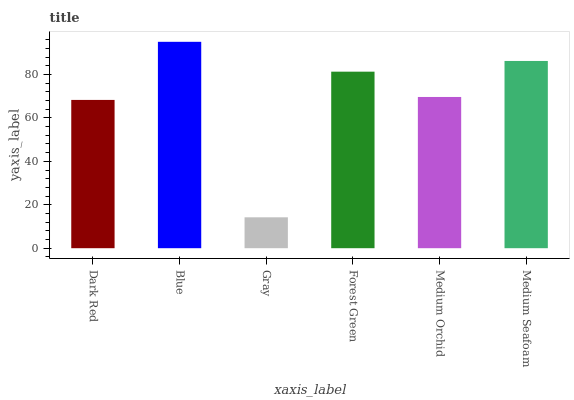Is Gray the minimum?
Answer yes or no. Yes. Is Blue the maximum?
Answer yes or no. Yes. Is Blue the minimum?
Answer yes or no. No. Is Gray the maximum?
Answer yes or no. No. Is Blue greater than Gray?
Answer yes or no. Yes. Is Gray less than Blue?
Answer yes or no. Yes. Is Gray greater than Blue?
Answer yes or no. No. Is Blue less than Gray?
Answer yes or no. No. Is Forest Green the high median?
Answer yes or no. Yes. Is Medium Orchid the low median?
Answer yes or no. Yes. Is Blue the high median?
Answer yes or no. No. Is Forest Green the low median?
Answer yes or no. No. 